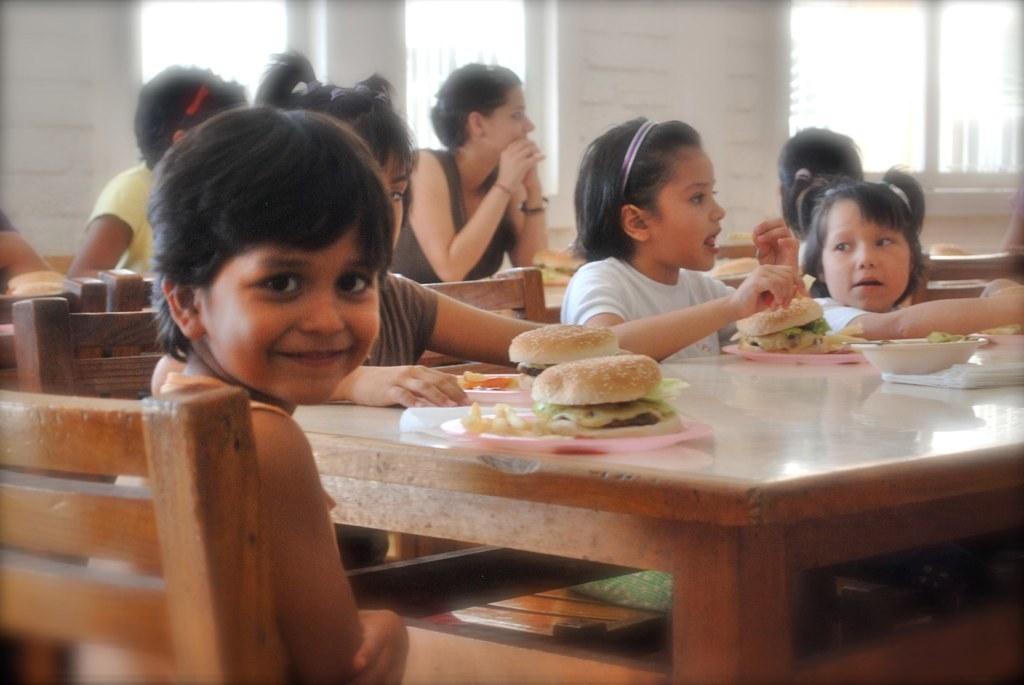Could you give a brief overview of what you see in this image? There is a room. There is a group of people. They are siting on chairs. On the left side we have a girl. She is smiling. There is a table. There is a pizza,tray ,bowl on a table. We can see in background window and wall. 